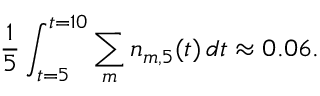Convert formula to latex. <formula><loc_0><loc_0><loc_500><loc_500>\frac { 1 } { 5 } \int _ { t = 5 } ^ { t = 1 0 } \sum _ { m } n _ { m , 5 } ( t ) \, d t \approx 0 . 0 6 .</formula> 